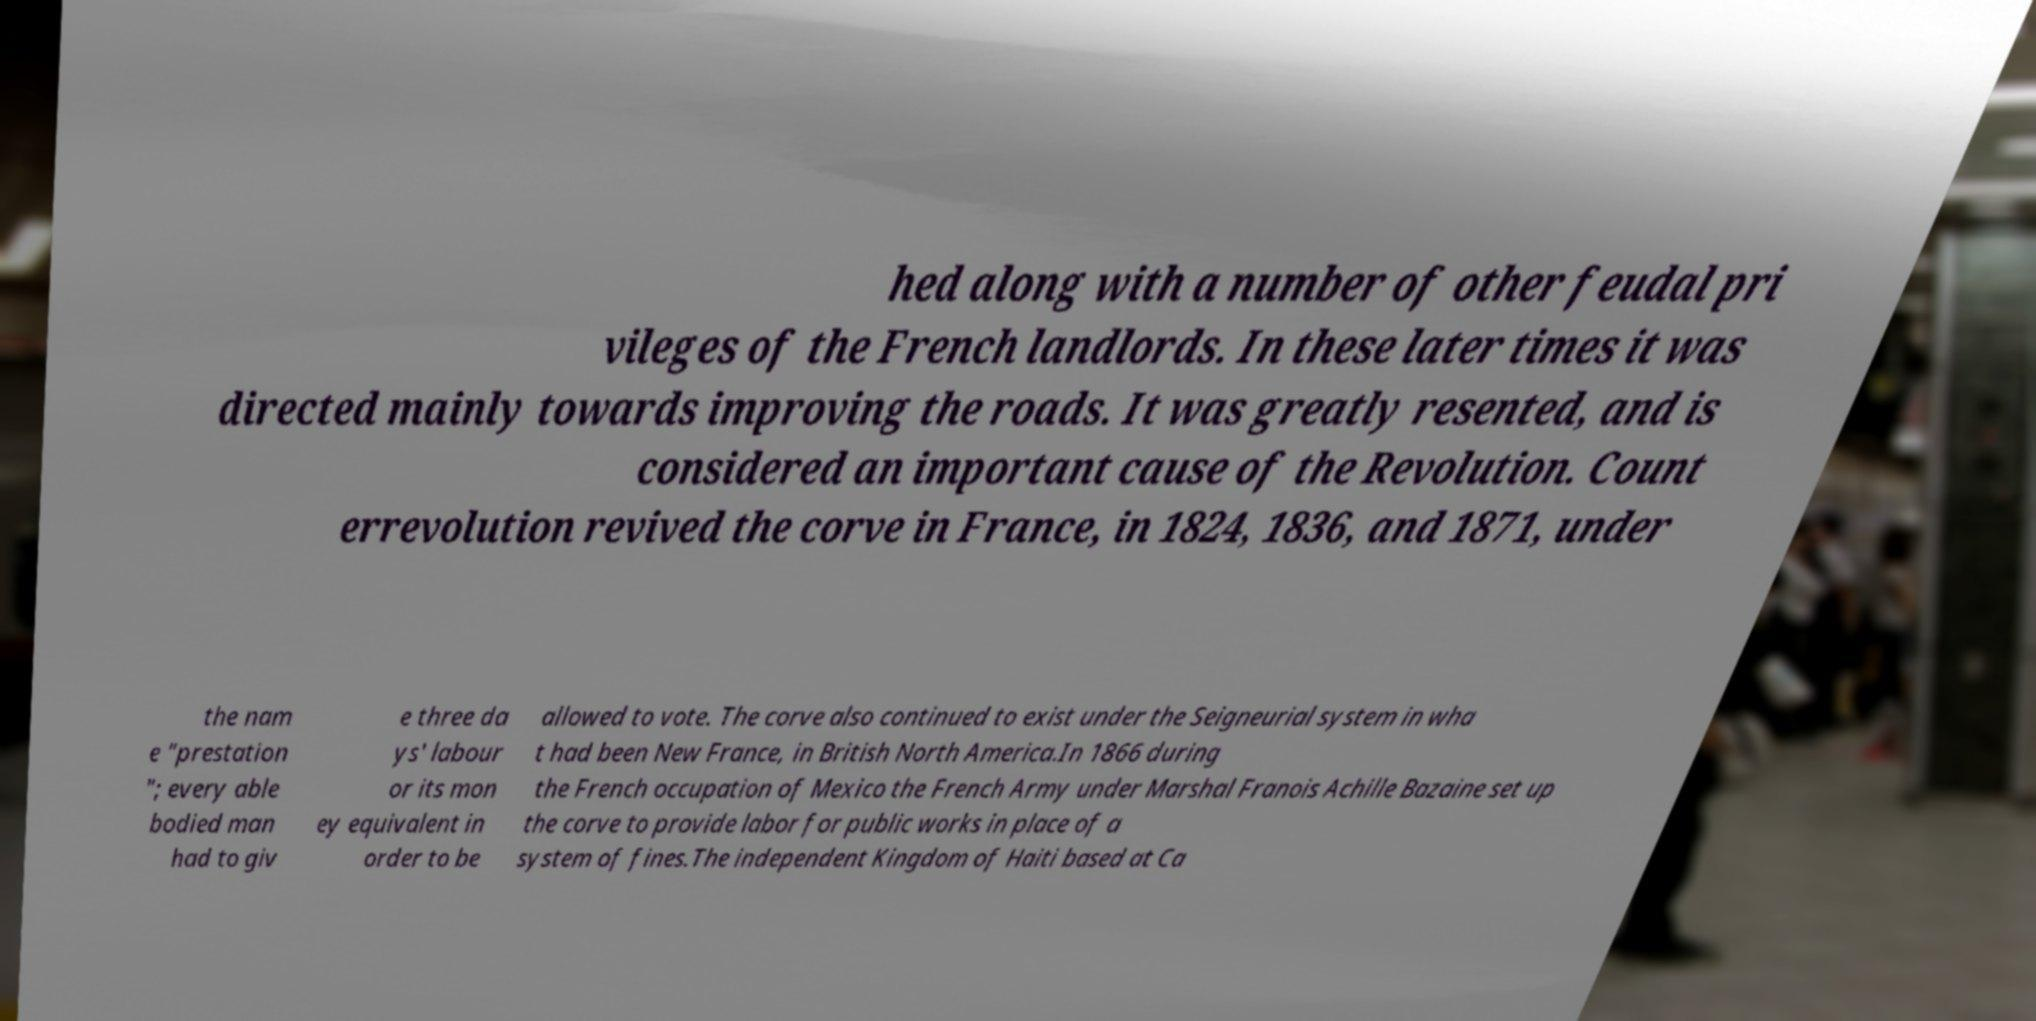Could you extract and type out the text from this image? hed along with a number of other feudal pri vileges of the French landlords. In these later times it was directed mainly towards improving the roads. It was greatly resented, and is considered an important cause of the Revolution. Count errevolution revived the corve in France, in 1824, 1836, and 1871, under the nam e "prestation "; every able bodied man had to giv e three da ys' labour or its mon ey equivalent in order to be allowed to vote. The corve also continued to exist under the Seigneurial system in wha t had been New France, in British North America.In 1866 during the French occupation of Mexico the French Army under Marshal Franois Achille Bazaine set up the corve to provide labor for public works in place of a system of fines.The independent Kingdom of Haiti based at Ca 